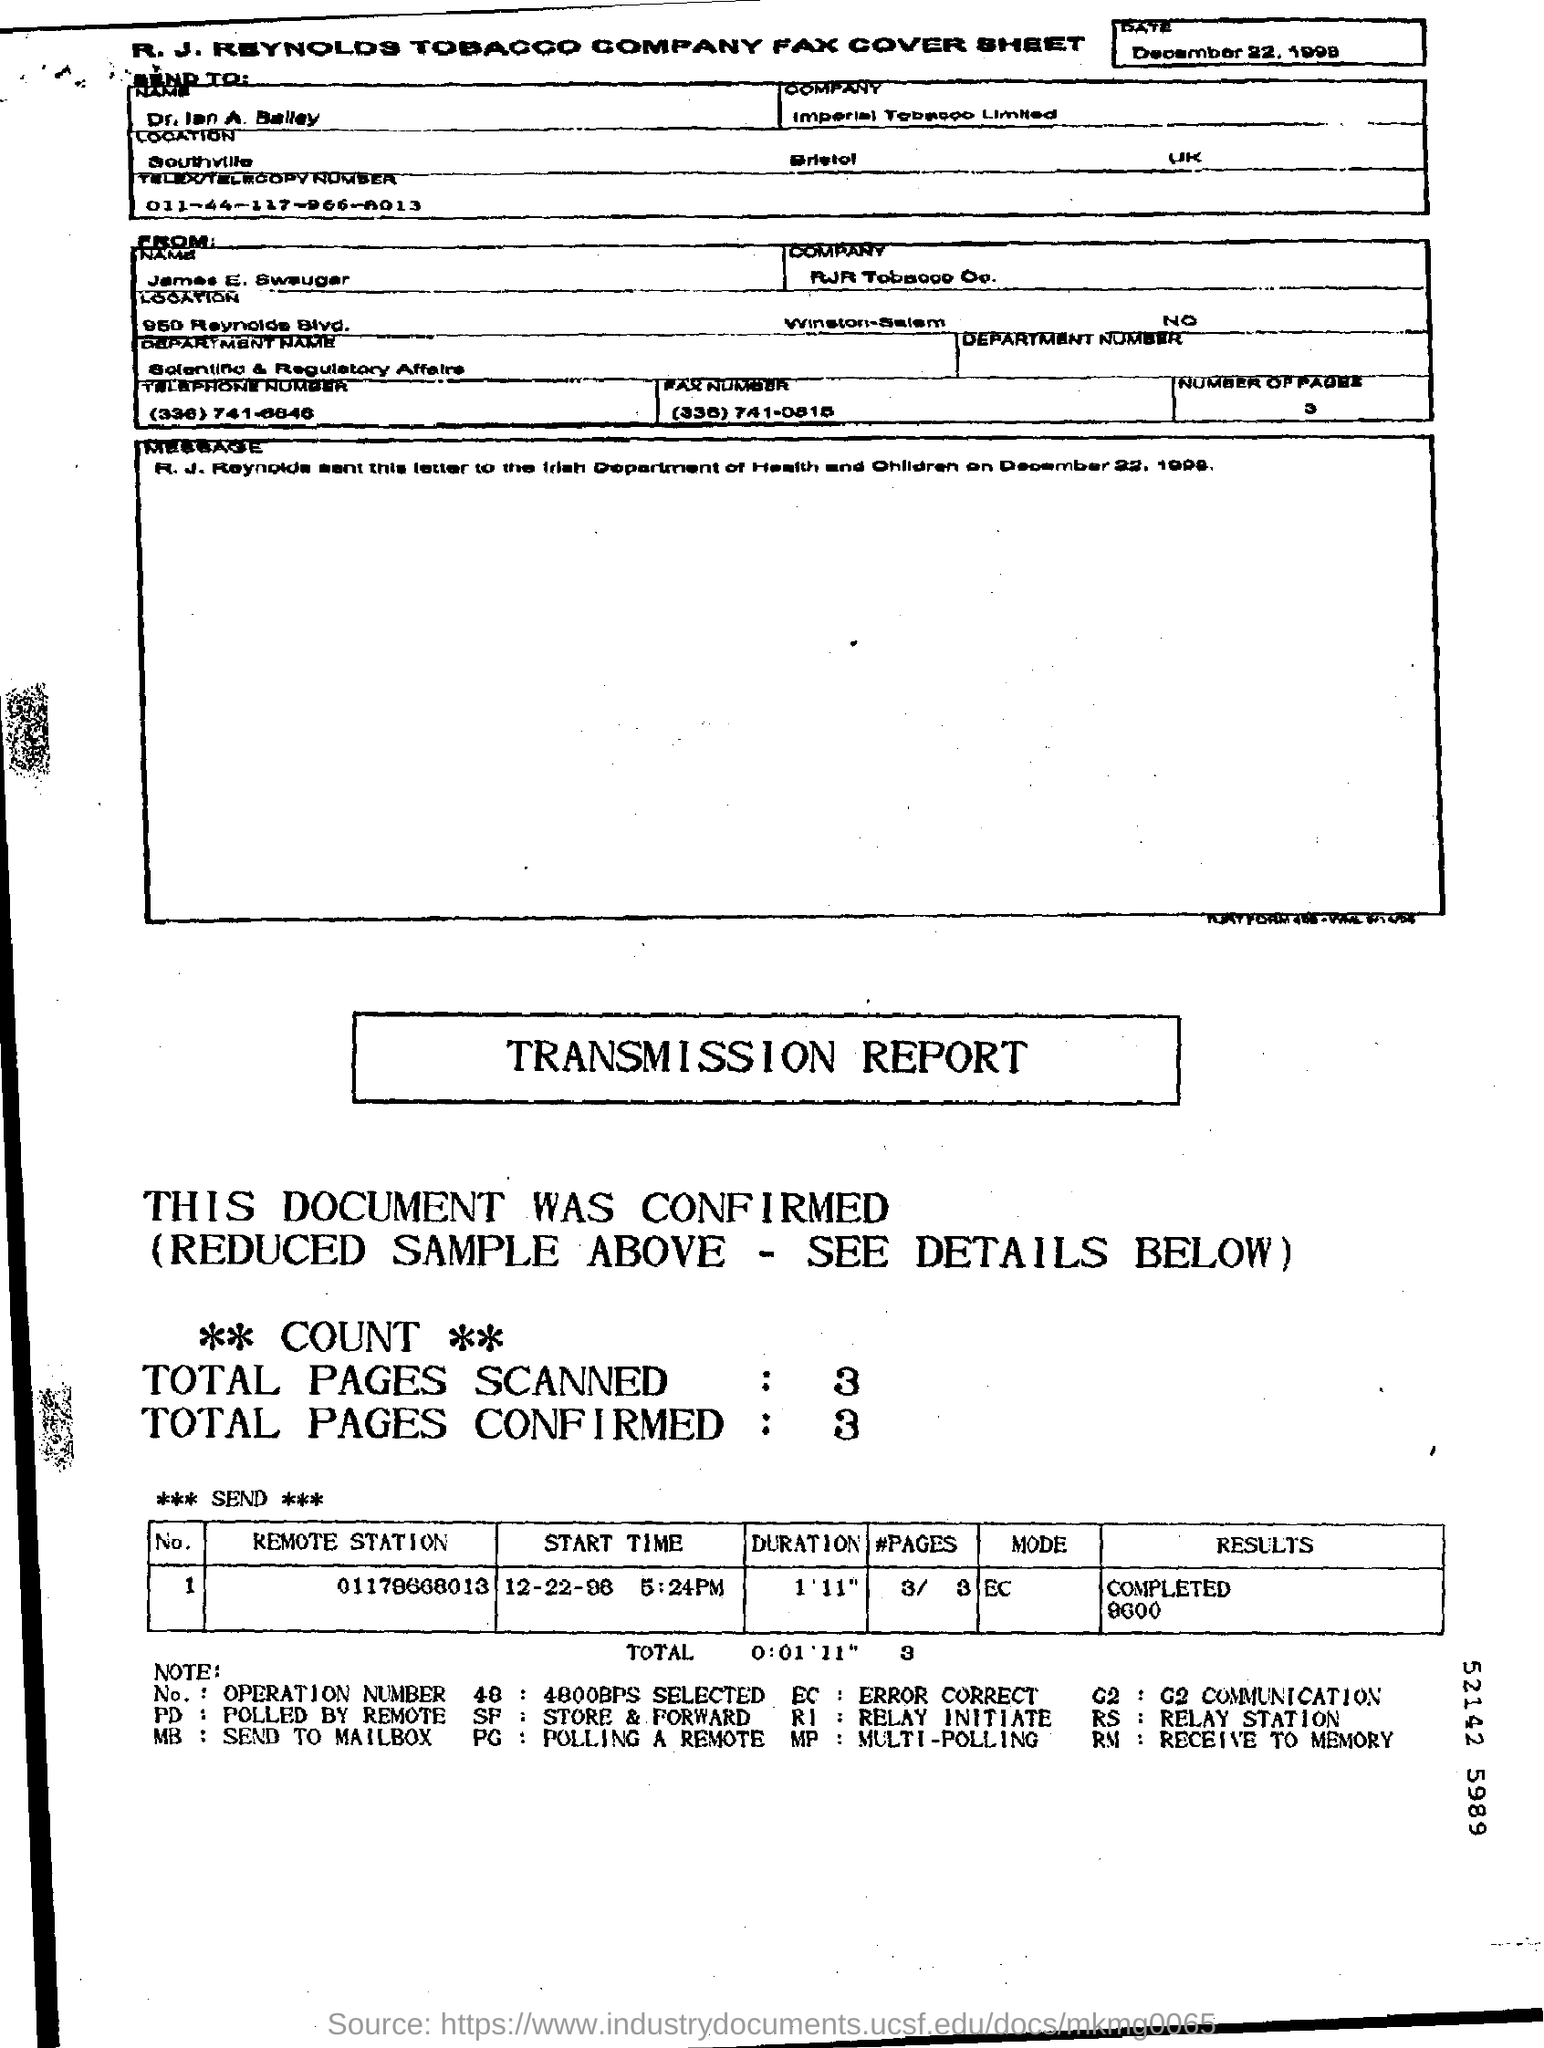How many total pages are scanned in the transmission report ?
Your response must be concise. 3. How many total pages are confirmed in the transmission report ?
Your answer should be compact. 3. What is the mode mentioned in the transmission report ?
Ensure brevity in your answer.  EC. What is the result given in the transmission report ?
Give a very brief answer. COMPLETED 9600. 